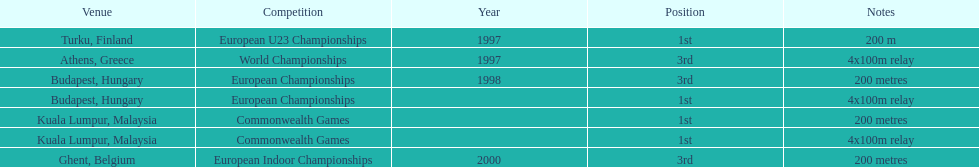Would you mind parsing the complete table? {'header': ['Venue', 'Competition', 'Year', 'Position', 'Notes'], 'rows': [['Turku, Finland', 'European U23 Championships', '1997', '1st', '200 m'], ['Athens, Greece', 'World Championships', '1997', '3rd', '4x100m relay'], ['Budapest, Hungary', 'European Championships', '1998', '3rd', '200 metres'], ['Budapest, Hungary', 'European Championships', '', '1st', '4x100m relay'], ['Kuala Lumpur, Malaysia', 'Commonwealth Games', '', '1st', '200 metres'], ['Kuala Lumpur, Malaysia', 'Commonwealth Games', '', '1st', '4x100m relay'], ['Ghent, Belgium', 'European Indoor Championships', '2000', '3rd', '200 metres']]} How many events were won in malaysia? 2. 